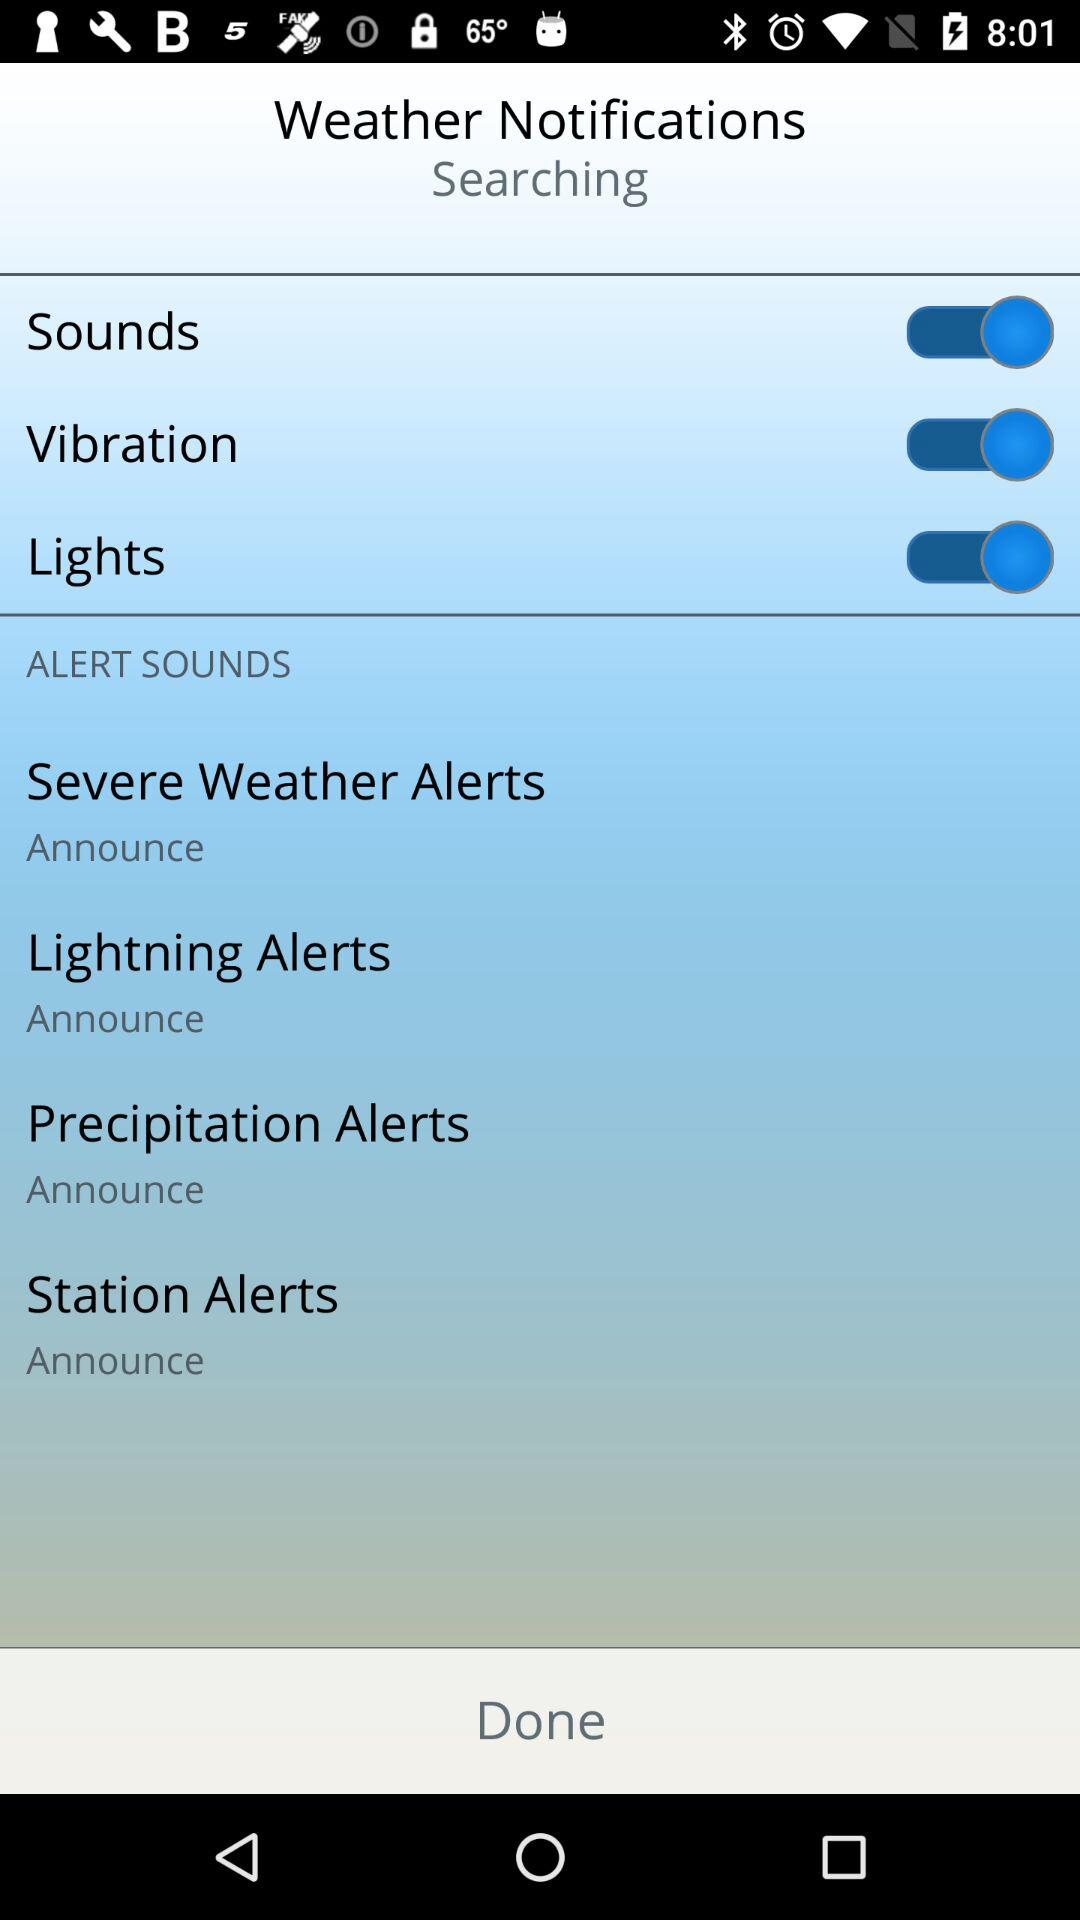What is the current status of the "Lights"? The status is "on". 